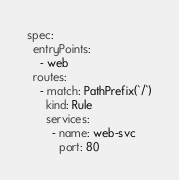<code> <loc_0><loc_0><loc_500><loc_500><_YAML_>spec:
  entryPoints:
    - web
  routes:
    - match: PathPrefix(`/`)
      kind: Rule
      services:
        - name: web-svc
          port: 80
</code> 